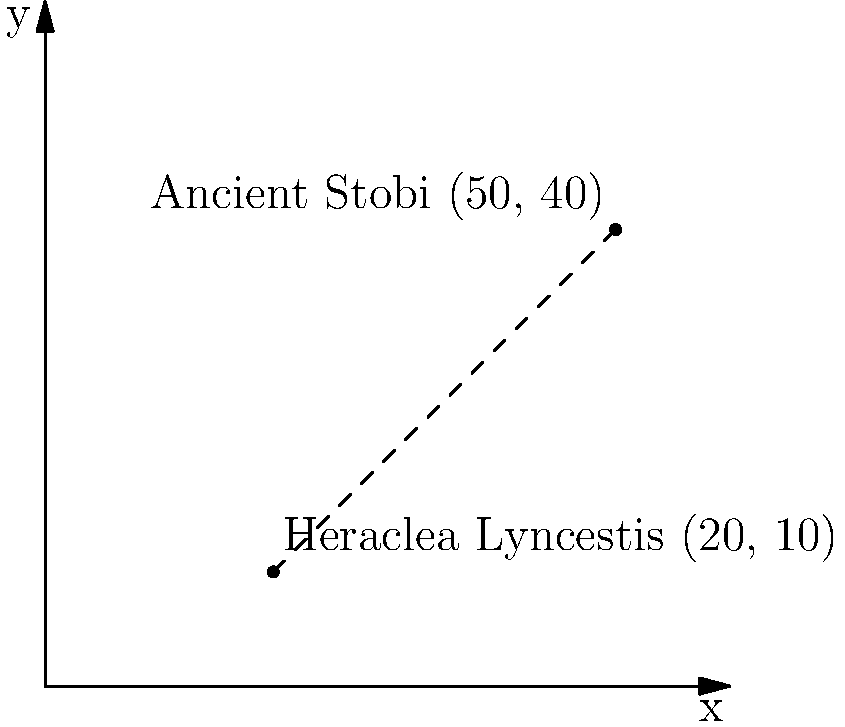Two significant historical sites in Macedonia, Heraclea Lyncestis and Ancient Stobi, are represented on a coordinate plane. Heraclea Lyncestis is located at (20, 10), and Ancient Stobi is at (50, 40). Calculate the straight-line distance between these two archaeological sites using the distance formula. Round your answer to the nearest kilometer. To find the distance between two points, we use the distance formula:

$$ d = \sqrt{(x_2 - x_1)^2 + (y_2 - y_1)^2} $$

Where $(x_1, y_1)$ is the coordinate of Heraclea Lyncestis (20, 10) and $(x_2, y_2)$ is the coordinate of Ancient Stobi (50, 40).

Step 1: Substitute the values into the formula:
$$ d = \sqrt{(50 - 20)^2 + (40 - 10)^2} $$

Step 2: Simplify inside the parentheses:
$$ d = \sqrt{30^2 + 30^2} $$

Step 3: Calculate the squares:
$$ d = \sqrt{900 + 900} $$

Step 4: Add under the square root:
$$ d = \sqrt{1800} $$

Step 5: Calculate the square root:
$$ d \approx 42.43 $$

Step 6: Round to the nearest kilometer:
$$ d \approx 42 \text{ km} $$

Therefore, the straight-line distance between Heraclea Lyncestis and Ancient Stobi is approximately 42 kilometers.
Answer: 42 km 